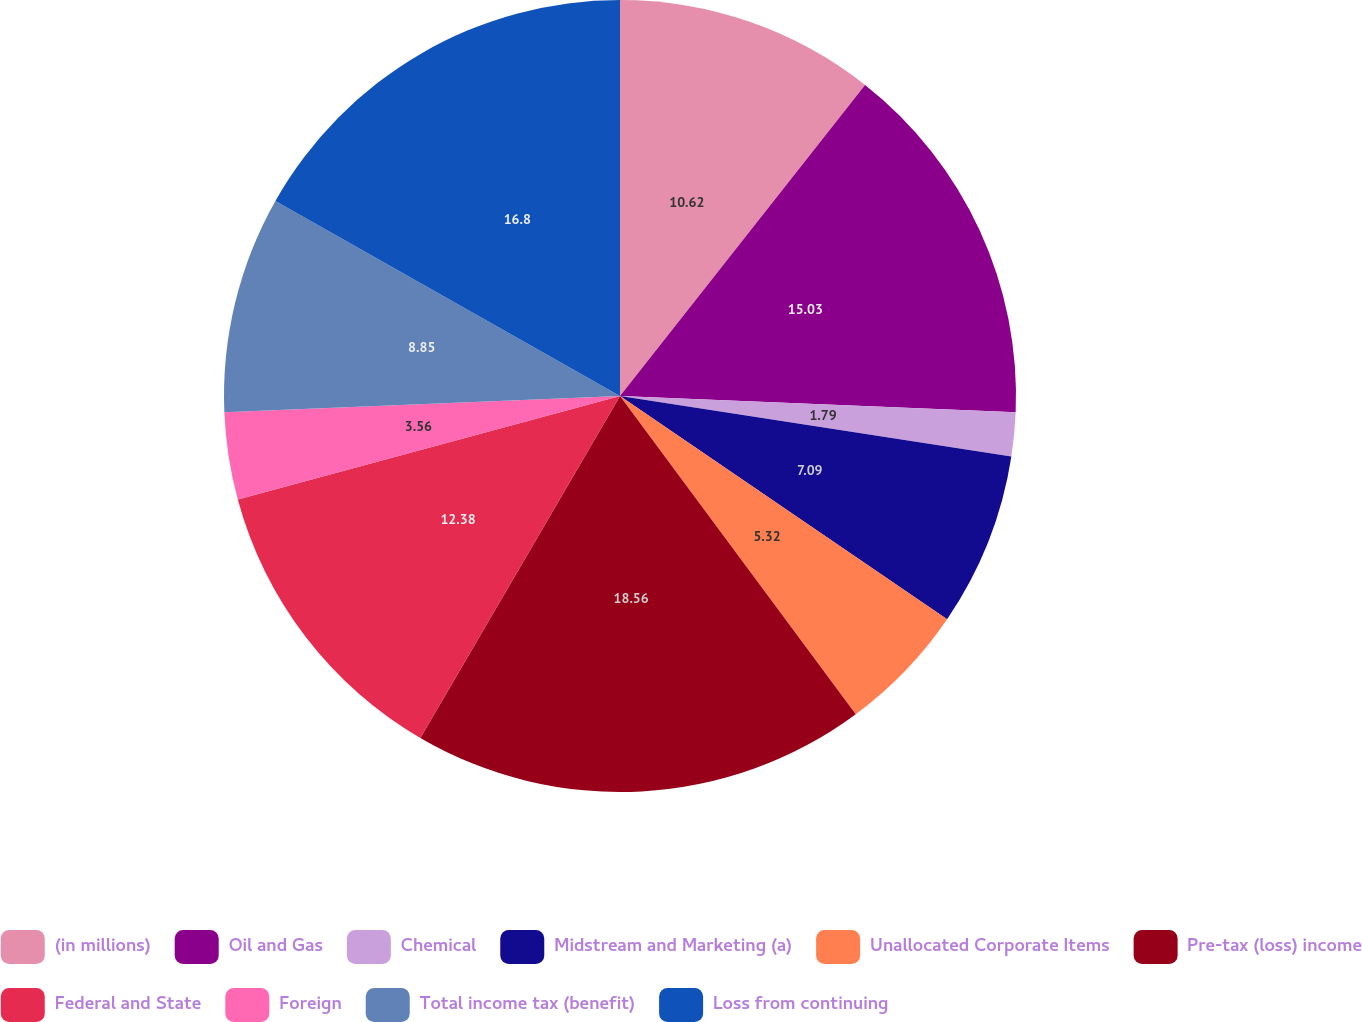<chart> <loc_0><loc_0><loc_500><loc_500><pie_chart><fcel>(in millions)<fcel>Oil and Gas<fcel>Chemical<fcel>Midstream and Marketing (a)<fcel>Unallocated Corporate Items<fcel>Pre-tax (loss) income<fcel>Federal and State<fcel>Foreign<fcel>Total income tax (benefit)<fcel>Loss from continuing<nl><fcel>10.62%<fcel>15.03%<fcel>1.79%<fcel>7.09%<fcel>5.32%<fcel>18.56%<fcel>12.38%<fcel>3.56%<fcel>8.85%<fcel>16.8%<nl></chart> 